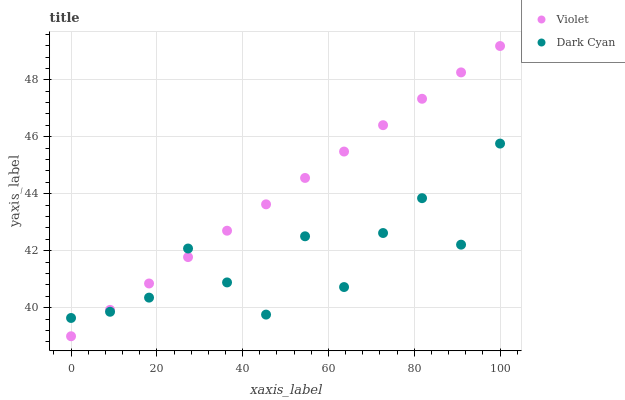Does Dark Cyan have the minimum area under the curve?
Answer yes or no. Yes. Does Violet have the maximum area under the curve?
Answer yes or no. Yes. Does Violet have the minimum area under the curve?
Answer yes or no. No. Is Violet the smoothest?
Answer yes or no. Yes. Is Dark Cyan the roughest?
Answer yes or no. Yes. Is Violet the roughest?
Answer yes or no. No. Does Violet have the lowest value?
Answer yes or no. Yes. Does Violet have the highest value?
Answer yes or no. Yes. Does Dark Cyan intersect Violet?
Answer yes or no. Yes. Is Dark Cyan less than Violet?
Answer yes or no. No. Is Dark Cyan greater than Violet?
Answer yes or no. No. 